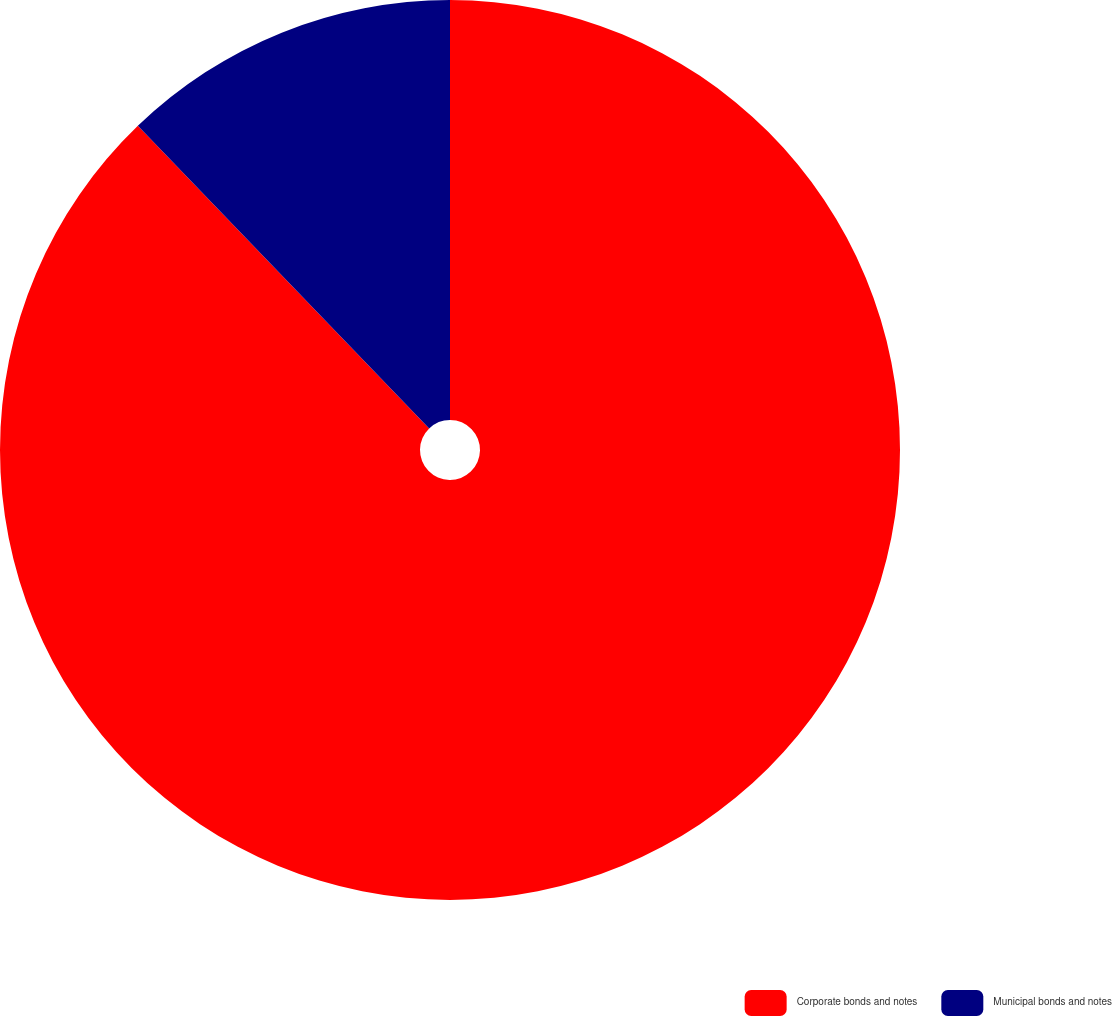Convert chart. <chart><loc_0><loc_0><loc_500><loc_500><pie_chart><fcel>Corporate bonds and notes<fcel>Municipal bonds and notes<nl><fcel>87.8%<fcel>12.2%<nl></chart> 